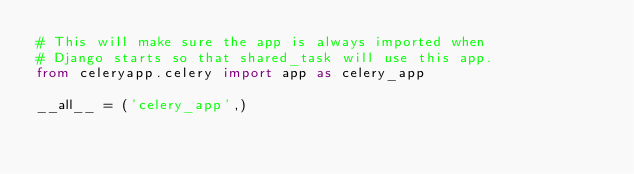<code> <loc_0><loc_0><loc_500><loc_500><_Python_># This will make sure the app is always imported when
# Django starts so that shared_task will use this app.
from celeryapp.celery import app as celery_app

__all__ = ('celery_app',)</code> 